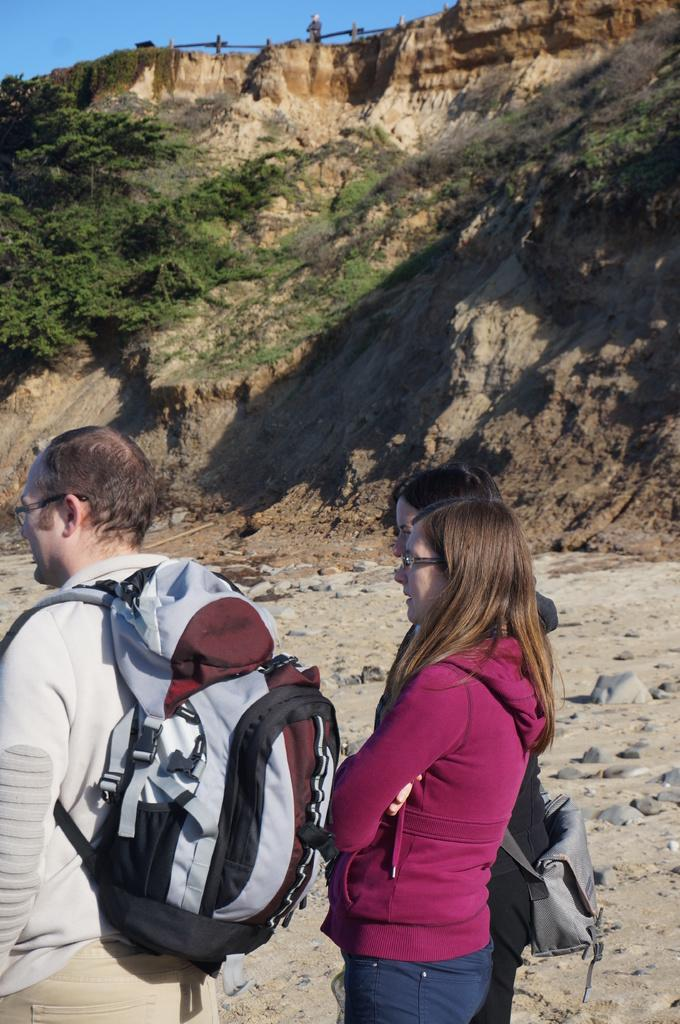How many people are in the image? There are three people in the image. Can you describe the gender of the people in the image? One of them is a man, and two of them are women. What are the people holding in the image? All three are holding bags on their shoulders. What can be seen in the background of the image? There is a hill in the background of the image, and there are trees on the hill. What type of chance game are the people playing in the image? There is no chance game present in the image; the people are holding bags on their shoulders. What type of celery can be seen growing on the hill in the image? There is no celery present in the image; the hill has trees, not celery. 